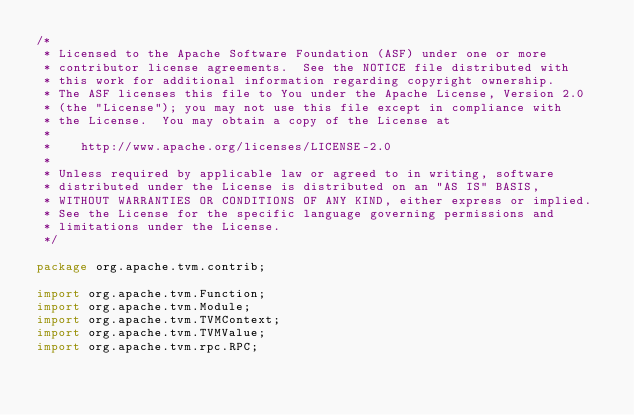<code> <loc_0><loc_0><loc_500><loc_500><_Java_>/*
 * Licensed to the Apache Software Foundation (ASF) under one or more
 * contributor license agreements.  See the NOTICE file distributed with
 * this work for additional information regarding copyright ownership.
 * The ASF licenses this file to You under the Apache License, Version 2.0
 * (the "License"); you may not use this file except in compliance with
 * the License.  You may obtain a copy of the License at
 *
 *    http://www.apache.org/licenses/LICENSE-2.0
 *
 * Unless required by applicable law or agreed to in writing, software
 * distributed under the License is distributed on an "AS IS" BASIS,
 * WITHOUT WARRANTIES OR CONDITIONS OF ANY KIND, either express or implied.
 * See the License for the specific language governing permissions and
 * limitations under the License.
 */

package org.apache.tvm.contrib;

import org.apache.tvm.Function;
import org.apache.tvm.Module;
import org.apache.tvm.TVMContext;
import org.apache.tvm.TVMValue;
import org.apache.tvm.rpc.RPC;</code> 